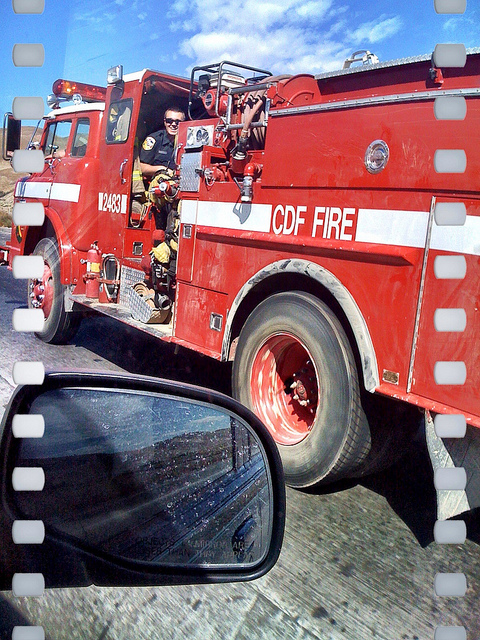What might be the reason for the firefighter's presence on the road? The firefighters are likely on the road responding to an emergency call, possibly en route to a fire incident, which could be a structure fire, a vehicle accident, or a wildfire, among other emergencies. Can you tell if they are currently engaged in an active emergency from this image? Based on the image, it's not possible to determine conclusively if they are actively engaged in an emergency. They could be returning from a call, in transit to a potential situation, or it could even be part of a routine patrol or training exercise. 